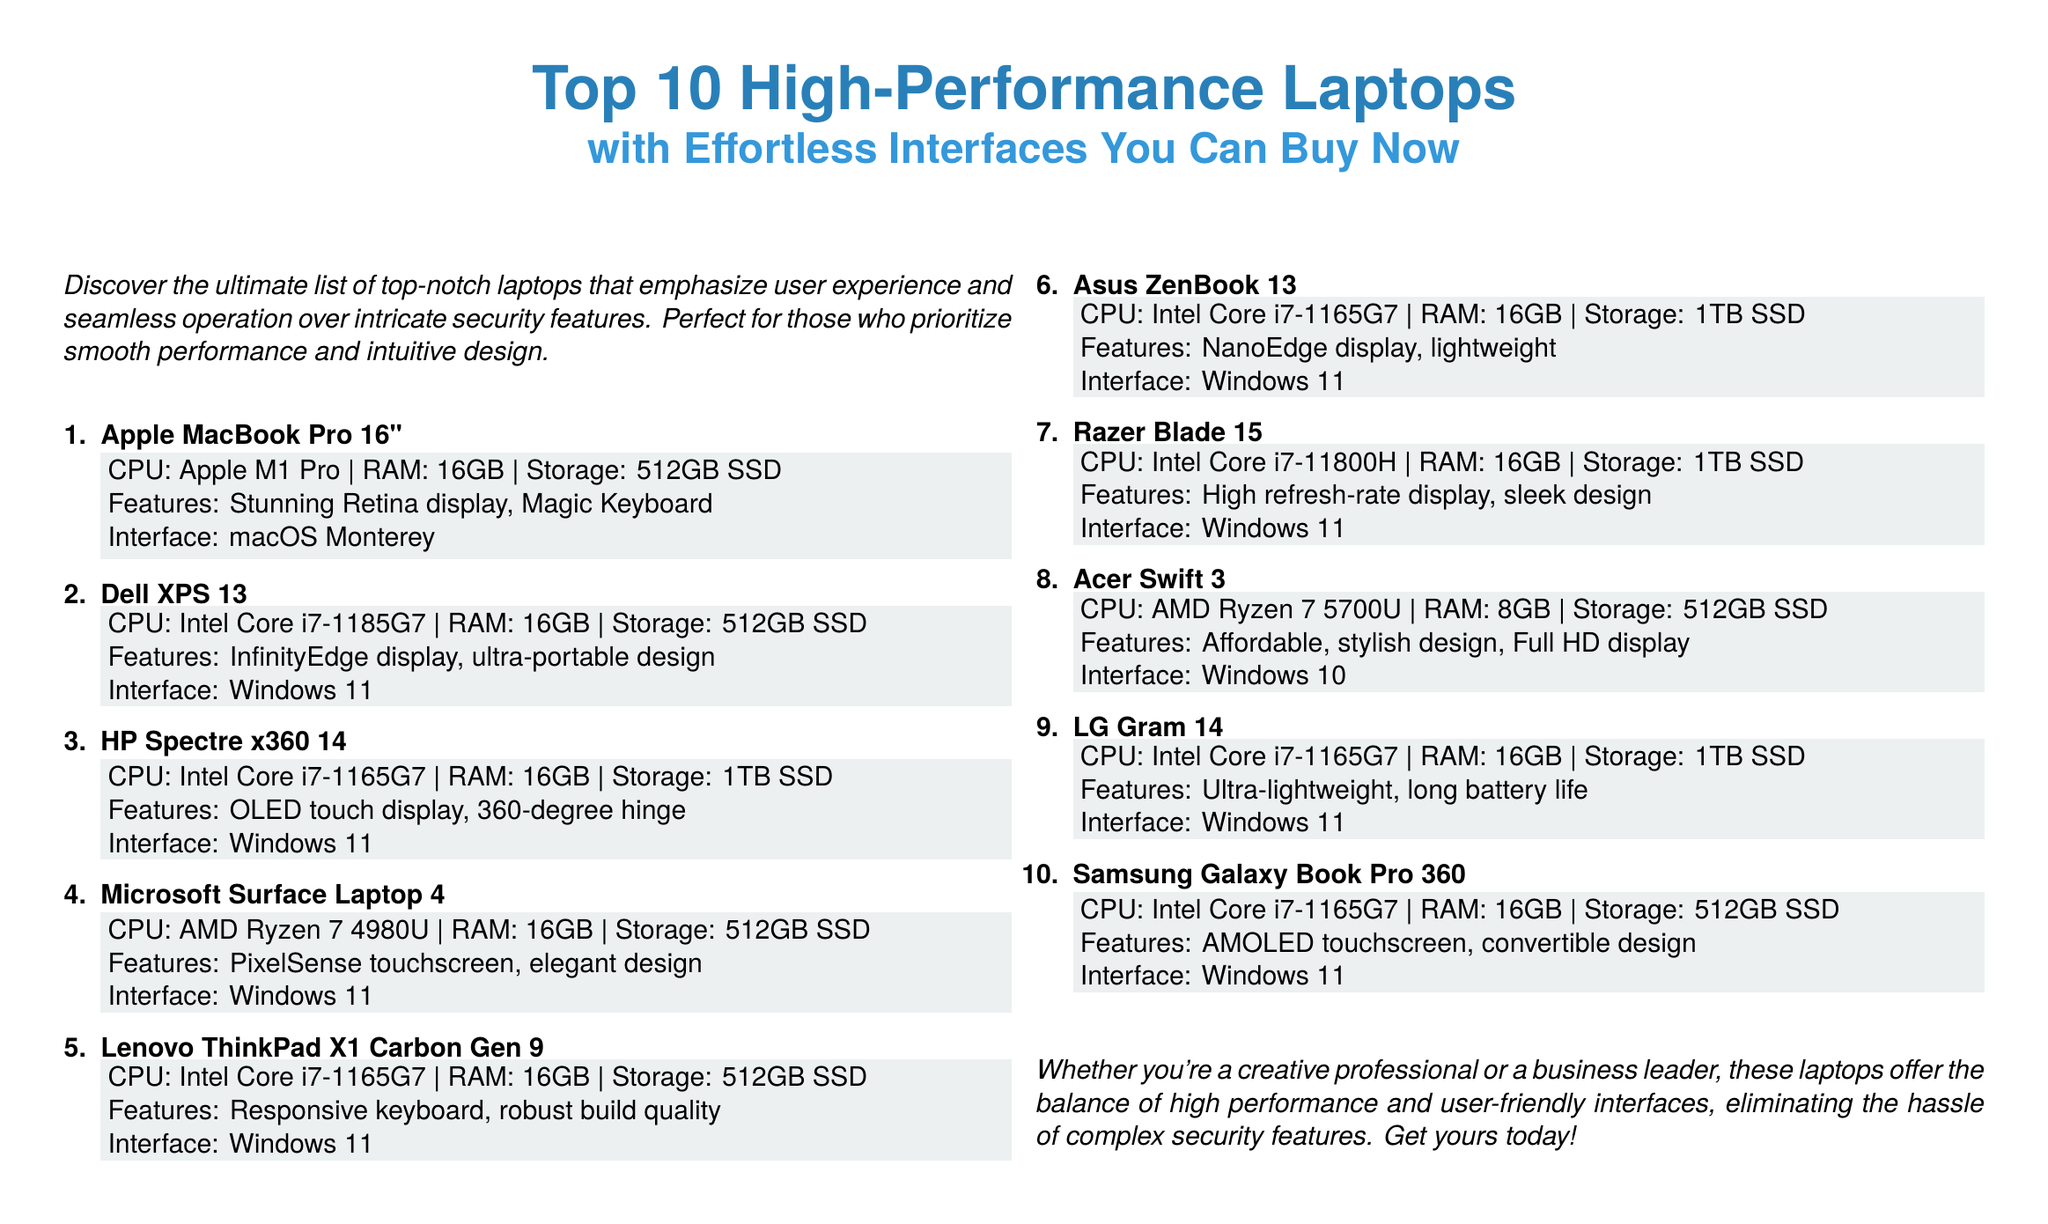What is the screen size of the Apple MacBook Pro? The document specifies that the Apple MacBook Pro has a screen size of 16 inches.
Answer: 16" What CPU does the Dell XPS 13 have? The Dell XPS 13 is equipped with an Intel Core i7-1185G7 CPU according to the document.
Answer: Intel Core i7-1185G7 How many laptops are featured in this flyer? The flyer lists a total of 10 high-performance laptops for review.
Answer: 10 Which laptop has an OLED touch display? The HP Spectre x360 14 is noted to feature an OLED touch display in the content of the flyer.
Answer: HP Spectre x360 14 What is the storage capacity of the Acer Swift 3? The Acer Swift 3 is documented to have a storage capacity of 512GB SSD.
Answer: 512GB SSD Which operating system is common among the listed laptops? The majority of laptops in the document run on Windows 11, highlighting its prevalence in the list.
Answer: Windows 11 What is emphasized over intricate security features in this flyer? The document emphasizes user experience and seamless operation as the main focus for the featured laptops.
Answer: User experience Which laptop is described as ultra-portable? The Dell XPS 13 is described with an ultra-portable design in the flyer.
Answer: Dell XPS 13 What type of design does the Samsung Galaxy Book Pro 360 feature? The Samsung Galaxy Book Pro 360 features a convertible design according to the provided information.
Answer: Convertible design 